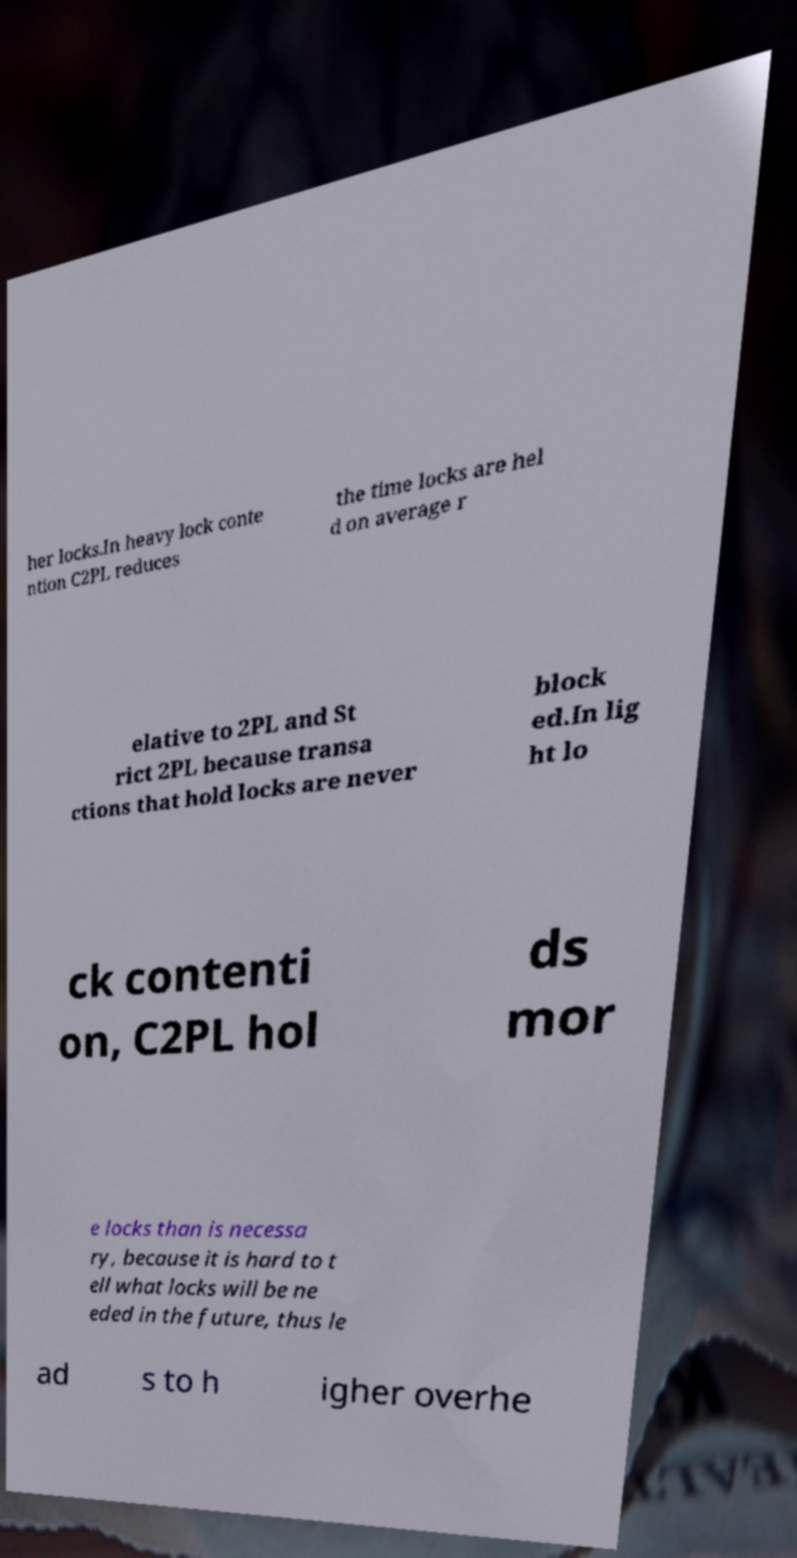Please read and relay the text visible in this image. What does it say? her locks.In heavy lock conte ntion C2PL reduces the time locks are hel d on average r elative to 2PL and St rict 2PL because transa ctions that hold locks are never block ed.In lig ht lo ck contenti on, C2PL hol ds mor e locks than is necessa ry, because it is hard to t ell what locks will be ne eded in the future, thus le ad s to h igher overhe 